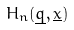Convert formula to latex. <formula><loc_0><loc_0><loc_500><loc_500>H _ { n } ( \underline { q } , \underline { x } )</formula> 